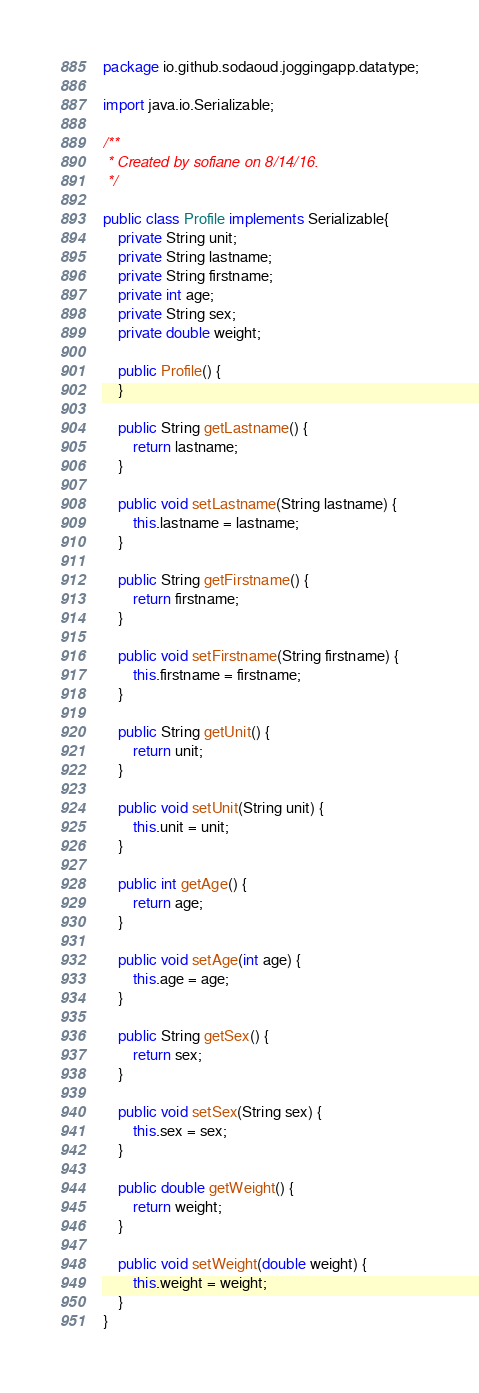<code> <loc_0><loc_0><loc_500><loc_500><_Java_>package io.github.sodaoud.joggingapp.datatype;

import java.io.Serializable;

/**
 * Created by sofiane on 8/14/16.
 */

public class Profile implements Serializable{
    private String unit;
    private String lastname;
    private String firstname;
    private int age;
    private String sex;
    private double weight;

    public Profile() {
    }

    public String getLastname() {
        return lastname;
    }

    public void setLastname(String lastname) {
        this.lastname = lastname;
    }

    public String getFirstname() {
        return firstname;
    }

    public void setFirstname(String firstname) {
        this.firstname = firstname;
    }

    public String getUnit() {
        return unit;
    }

    public void setUnit(String unit) {
        this.unit = unit;
    }

    public int getAge() {
        return age;
    }

    public void setAge(int age) {
        this.age = age;
    }

    public String getSex() {
        return sex;
    }

    public void setSex(String sex) {
        this.sex = sex;
    }

    public double getWeight() {
        return weight;
    }

    public void setWeight(double weight) {
        this.weight = weight;
    }
}
</code> 